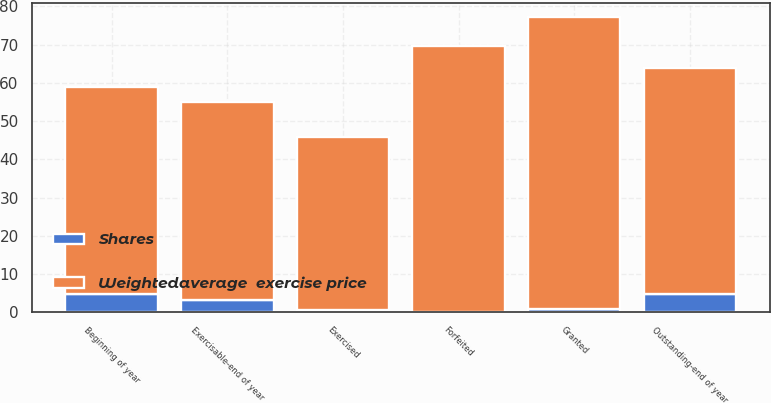<chart> <loc_0><loc_0><loc_500><loc_500><stacked_bar_chart><ecel><fcel>Beginning of year<fcel>Granted<fcel>Exercised<fcel>Forfeited<fcel>Outstanding-end of year<fcel>Exercisable-end of year<nl><fcel>Shares<fcel>4.8<fcel>0.8<fcel>0.7<fcel>0.1<fcel>4.8<fcel>3.1<nl><fcel>Weightedaverage  exercise price<fcel>54.17<fcel>76.32<fcel>45.22<fcel>69.67<fcel>59.2<fcel>51.99<nl></chart> 